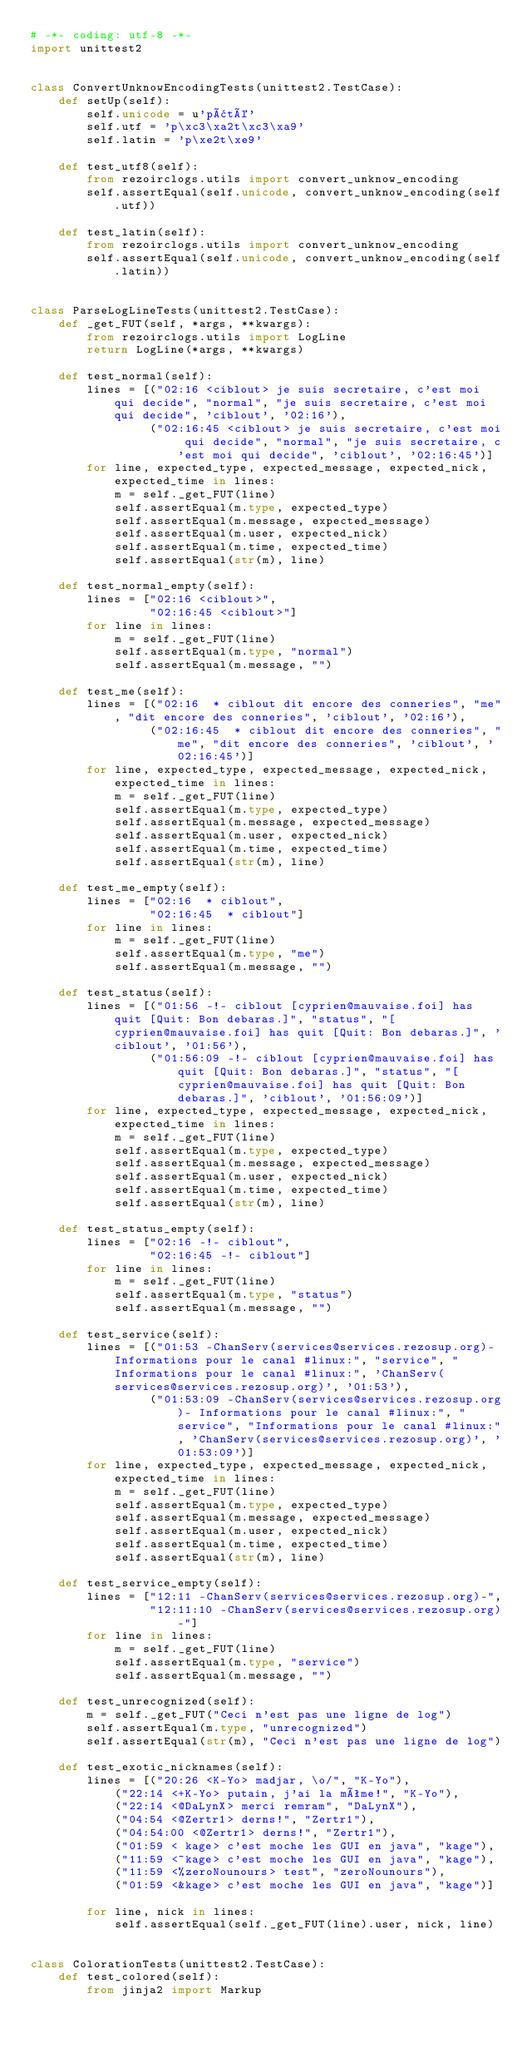<code> <loc_0><loc_0><loc_500><loc_500><_Python_># -*- coding: utf-8 -*-
import unittest2


class ConvertUnknowEncodingTests(unittest2.TestCase):
    def setUp(self):
        self.unicode = u'pâté'
        self.utf = 'p\xc3\xa2t\xc3\xa9'
        self.latin = 'p\xe2t\xe9'

    def test_utf8(self):
        from rezoirclogs.utils import convert_unknow_encoding
        self.assertEqual(self.unicode, convert_unknow_encoding(self.utf))

    def test_latin(self):
        from rezoirclogs.utils import convert_unknow_encoding
        self.assertEqual(self.unicode, convert_unknow_encoding(self.latin))


class ParseLogLineTests(unittest2.TestCase):
    def _get_FUT(self, *args, **kwargs):
        from rezoirclogs.utils import LogLine
        return LogLine(*args, **kwargs)

    def test_normal(self):
        lines = [("02:16 <ciblout> je suis secretaire, c'est moi qui decide", "normal", "je suis secretaire, c'est moi qui decide", 'ciblout', '02:16'),
                 ("02:16:45 <ciblout> je suis secretaire, c'est moi qui decide", "normal", "je suis secretaire, c'est moi qui decide", 'ciblout', '02:16:45')]
        for line, expected_type, expected_message, expected_nick, expected_time in lines:
            m = self._get_FUT(line)
            self.assertEqual(m.type, expected_type)
            self.assertEqual(m.message, expected_message)
            self.assertEqual(m.user, expected_nick)
            self.assertEqual(m.time, expected_time)
            self.assertEqual(str(m), line)

    def test_normal_empty(self):
        lines = ["02:16 <ciblout>",
                 "02:16:45 <ciblout>"]
        for line in lines:
            m = self._get_FUT(line)
            self.assertEqual(m.type, "normal")
            self.assertEqual(m.message, "")

    def test_me(self):
        lines = [("02:16  * ciblout dit encore des conneries", "me", "dit encore des conneries", 'ciblout', '02:16'),
                 ("02:16:45  * ciblout dit encore des conneries", "me", "dit encore des conneries", 'ciblout', '02:16:45')]
        for line, expected_type, expected_message, expected_nick, expected_time in lines:
            m = self._get_FUT(line)
            self.assertEqual(m.type, expected_type)
            self.assertEqual(m.message, expected_message)
            self.assertEqual(m.user, expected_nick)
            self.assertEqual(m.time, expected_time)
            self.assertEqual(str(m), line)

    def test_me_empty(self):
        lines = ["02:16  * ciblout",
                 "02:16:45  * ciblout"]
        for line in lines:
            m = self._get_FUT(line)
            self.assertEqual(m.type, "me")
            self.assertEqual(m.message, "")

    def test_status(self):
        lines = [("01:56 -!- ciblout [cyprien@mauvaise.foi] has quit [Quit: Bon debaras.]", "status", "[cyprien@mauvaise.foi] has quit [Quit: Bon debaras.]", 'ciblout', '01:56'),
                 ("01:56:09 -!- ciblout [cyprien@mauvaise.foi] has quit [Quit: Bon debaras.]", "status", "[cyprien@mauvaise.foi] has quit [Quit: Bon debaras.]", 'ciblout', '01:56:09')]
        for line, expected_type, expected_message, expected_nick, expected_time in lines:
            m = self._get_FUT(line)
            self.assertEqual(m.type, expected_type)
            self.assertEqual(m.message, expected_message)
            self.assertEqual(m.user, expected_nick)
            self.assertEqual(m.time, expected_time)
            self.assertEqual(str(m), line)

    def test_status_empty(self):
        lines = ["02:16 -!- ciblout",
                 "02:16:45 -!- ciblout"]
        for line in lines:
            m = self._get_FUT(line)
            self.assertEqual(m.type, "status")
            self.assertEqual(m.message, "")

    def test_service(self):
        lines = [("01:53 -ChanServ(services@services.rezosup.org)- Informations pour le canal #linux:", "service", "Informations pour le canal #linux:", 'ChanServ(services@services.rezosup.org)', '01:53'),
                 ("01:53:09 -ChanServ(services@services.rezosup.org)- Informations pour le canal #linux:", "service", "Informations pour le canal #linux:", 'ChanServ(services@services.rezosup.org)', '01:53:09')]
        for line, expected_type, expected_message, expected_nick, expected_time in lines:
            m = self._get_FUT(line)
            self.assertEqual(m.type, expected_type)
            self.assertEqual(m.message, expected_message)
            self.assertEqual(m.user, expected_nick)
            self.assertEqual(m.time, expected_time)
            self.assertEqual(str(m), line)

    def test_service_empty(self):
        lines = ["12:11 -ChanServ(services@services.rezosup.org)-",
                 "12:11:10 -ChanServ(services@services.rezosup.org)-"]
        for line in lines:
            m = self._get_FUT(line)
            self.assertEqual(m.type, "service")
            self.assertEqual(m.message, "")

    def test_unrecognized(self):
        m = self._get_FUT("Ceci n'est pas une ligne de log")
        self.assertEqual(m.type, "unrecognized")
        self.assertEqual(str(m), "Ceci n'est pas une ligne de log")

    def test_exotic_nicknames(self):
        lines = [("20:26 <K-Yo> madjar, \o/", "K-Yo"),
            ("22:14 <+K-Yo> putain, j'ai la même!", "K-Yo"),
            ("22:14 <@DaLynX> merci remram", "DaLynX"),
            ("04:54 <@Zertr1> derns!", "Zertr1"),
            ("04:54:00 <@Zertr1> derns!", "Zertr1"),
            ("01:59 < kage> c'est moche les GUI en java", "kage"),
            ("11:59 <~kage> c'est moche les GUI en java", "kage"),
            ("11:59 <%zeroNounours> test", "zeroNounours"),
            ("01:59 <&kage> c'est moche les GUI en java", "kage")]

        for line, nick in lines:
            self.assertEqual(self._get_FUT(line).user, nick, line)


class ColorationTests(unittest2.TestCase):
    def test_colored(self):
        from jinja2 import Markup</code> 